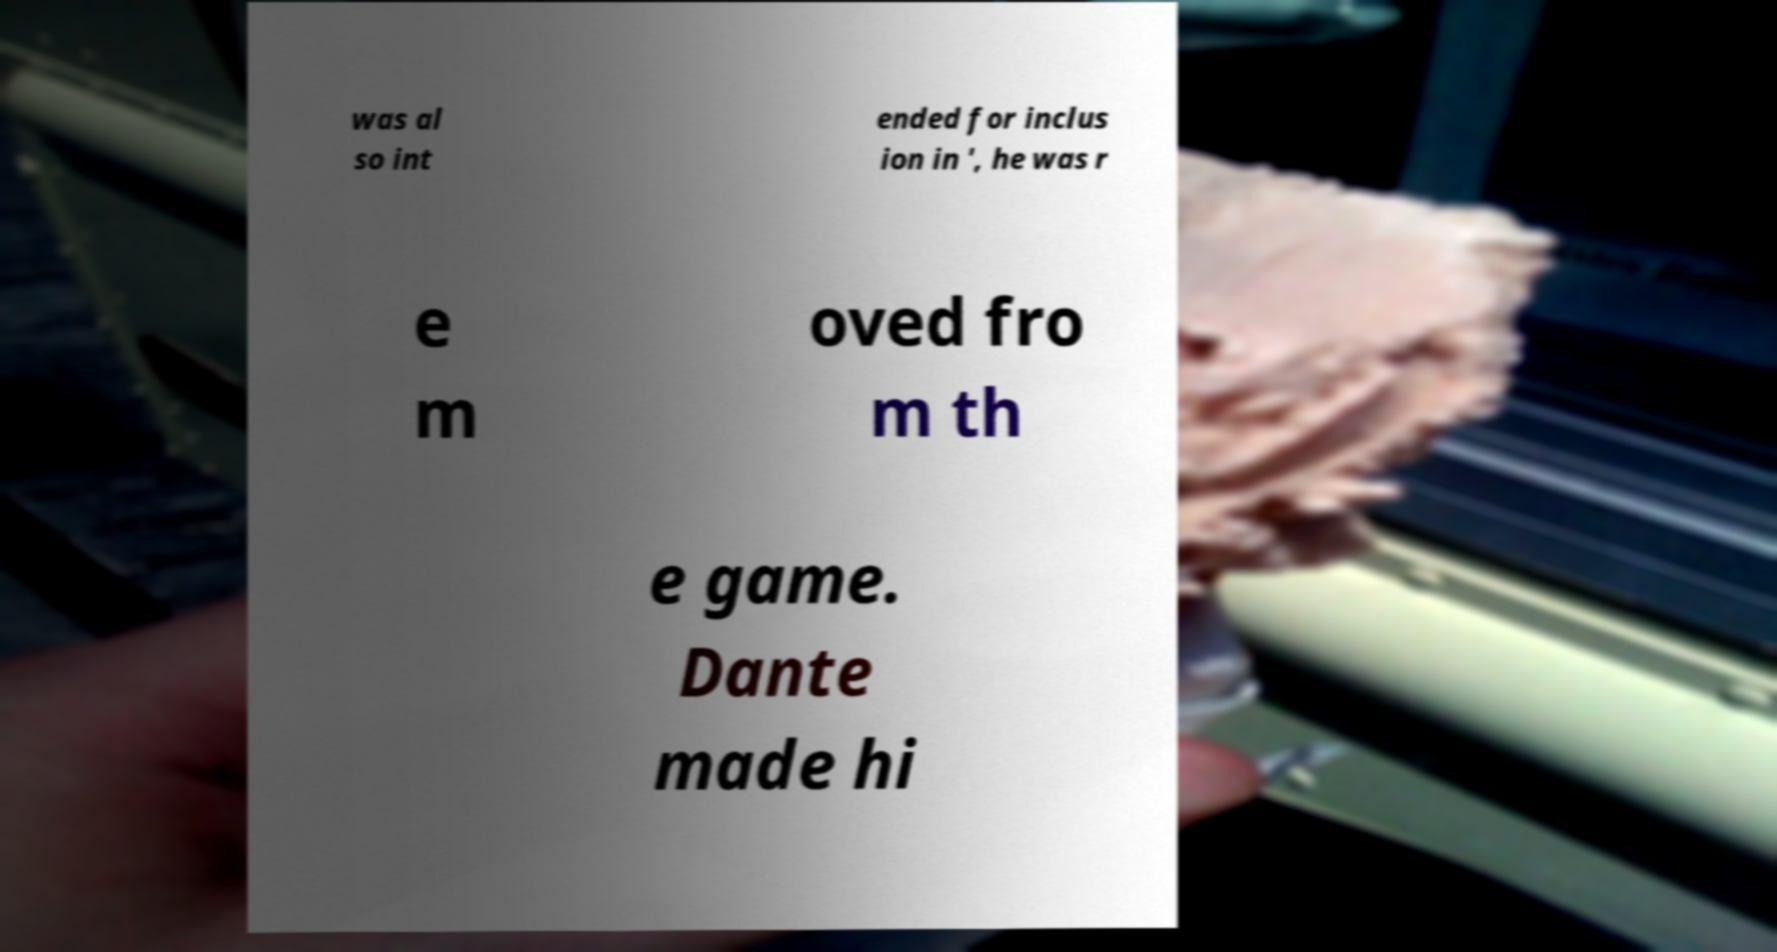There's text embedded in this image that I need extracted. Can you transcribe it verbatim? was al so int ended for inclus ion in ', he was r e m oved fro m th e game. Dante made hi 